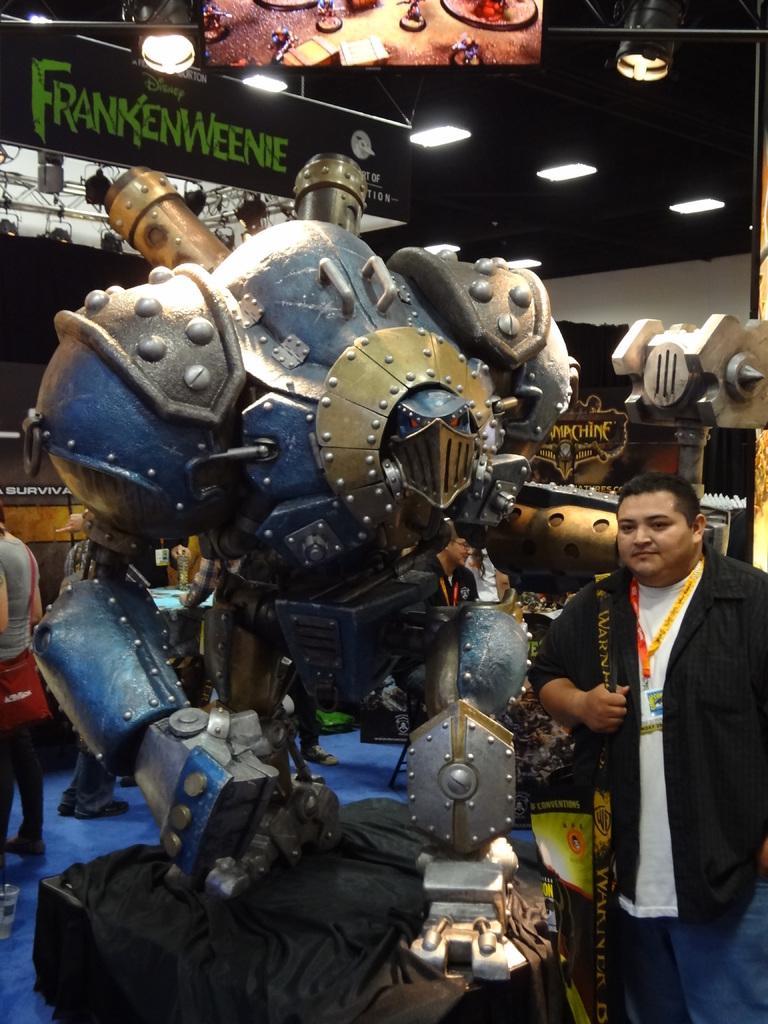Please provide a concise description of this image. In this picture, it seems to be there is a robot in the center of the image and there is a man who is standing on the right side of the image and there are spotlights, lamps, and posters in the image, there are people in the background area of the image. 